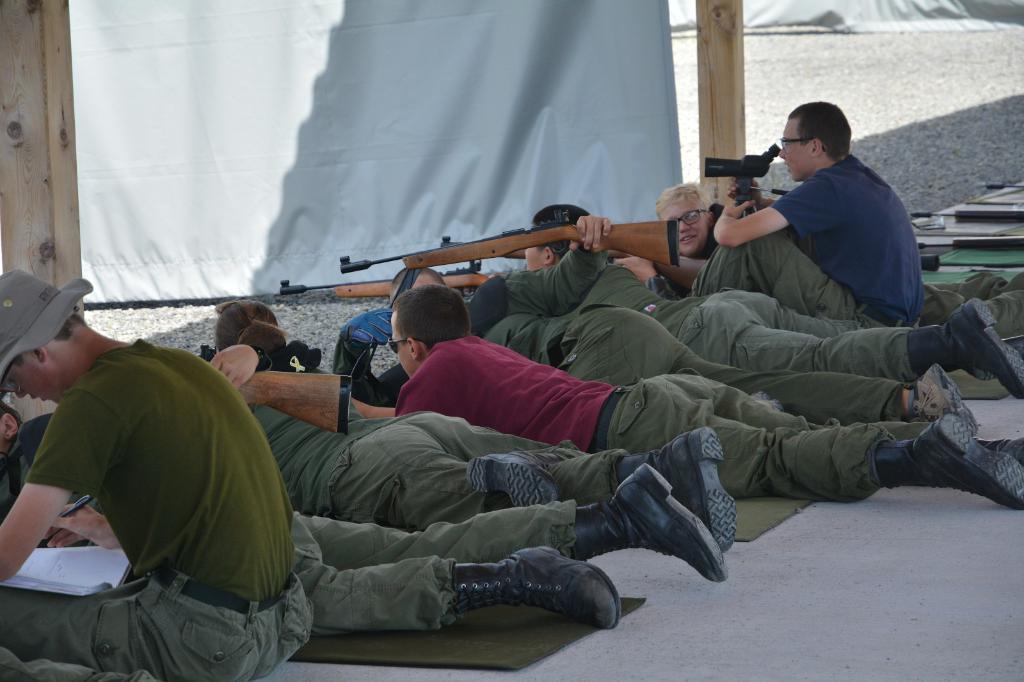Could you give a brief overview of what you see in this image? In the image in the center, we can see two persons are sitting and few people are lying and holding some objects. In the background we can see the curtains and poles. 